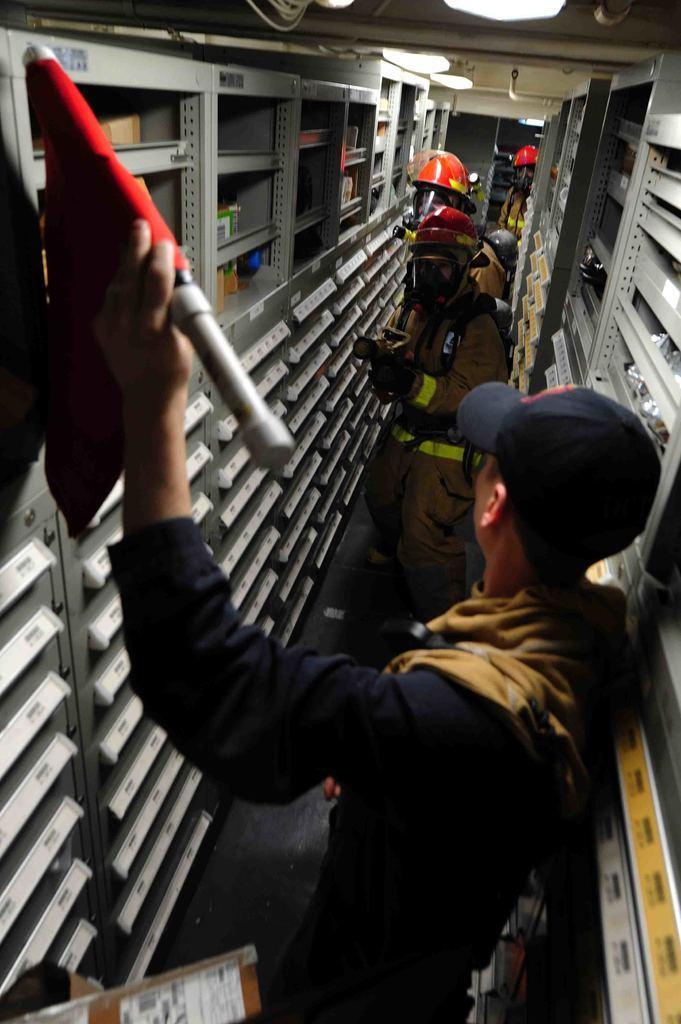In one or two sentences, can you explain what this image depicts? In this image there is a person holding an object. He is wearing a cap. He is standing on the floor. Before him there is a person wearing a helmet. There are people standing on the floor. Background there are racks. Top of the image there are lights attached to the roof. 